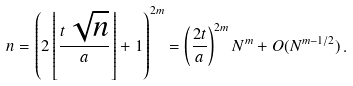<formula> <loc_0><loc_0><loc_500><loc_500>n = \left ( 2 \left \lfloor \frac { t \, \sqrt { n } } { a } \right \rfloor + 1 \right ) ^ { 2 m } = \left ( \frac { 2 t } { a } \right ) ^ { 2 m } N ^ { m } + O ( N ^ { m - 1 / 2 } ) \, .</formula> 